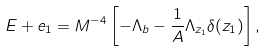<formula> <loc_0><loc_0><loc_500><loc_500>E + e _ { 1 } = M ^ { - 4 } \left [ - \Lambda _ { b } - \frac { 1 } { A } \Lambda _ { z _ { 1 } } \delta ( z _ { 1 } ) \right ] ,</formula> 